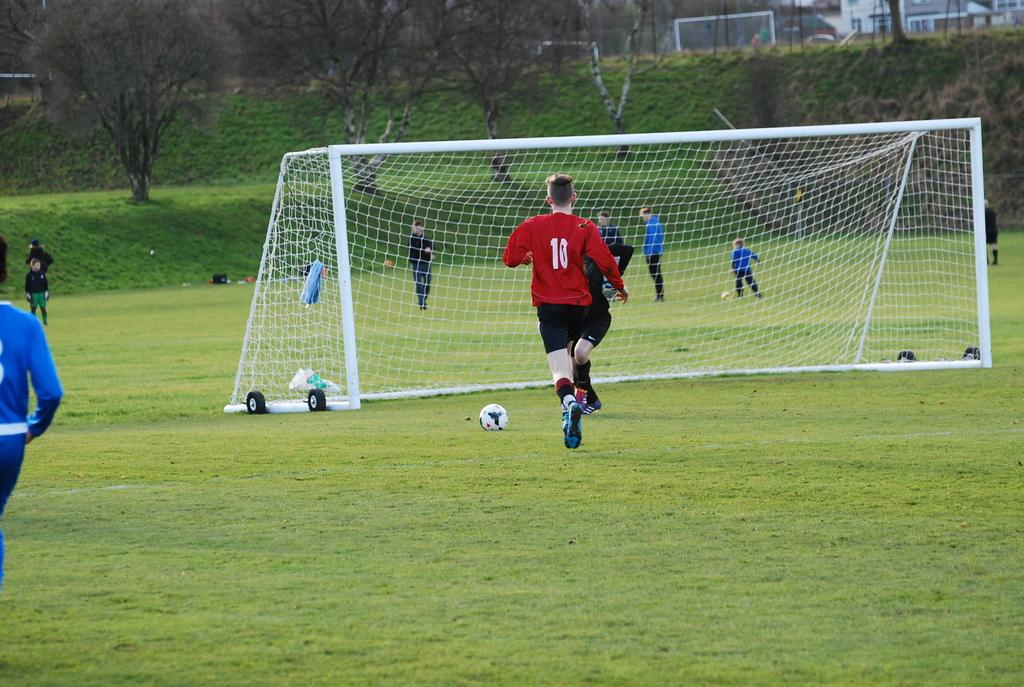Provide a one-sentence caption for the provided image. A man wearing number 10 jersey is running toward the goal post. 